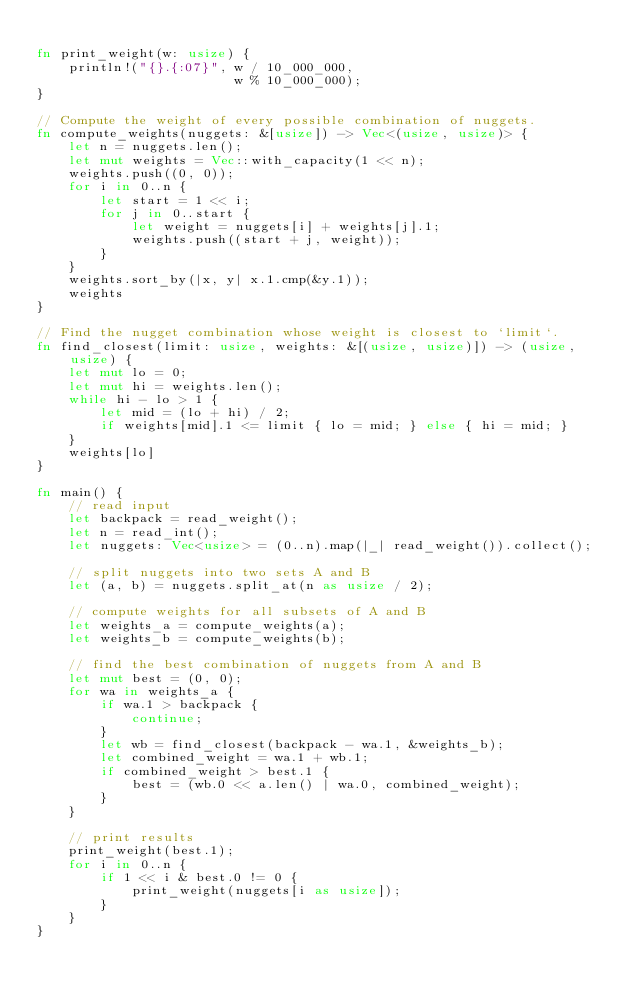<code> <loc_0><loc_0><loc_500><loc_500><_Rust_>
fn print_weight(w: usize) {
    println!("{}.{:07}", w / 10_000_000,
                         w % 10_000_000);
}

// Compute the weight of every possible combination of nuggets.
fn compute_weights(nuggets: &[usize]) -> Vec<(usize, usize)> {
    let n = nuggets.len();
    let mut weights = Vec::with_capacity(1 << n);
    weights.push((0, 0));
    for i in 0..n {
        let start = 1 << i;
        for j in 0..start {
            let weight = nuggets[i] + weights[j].1;
            weights.push((start + j, weight));
        }
    }
    weights.sort_by(|x, y| x.1.cmp(&y.1));
    weights
}

// Find the nugget combination whose weight is closest to `limit`.
fn find_closest(limit: usize, weights: &[(usize, usize)]) -> (usize, usize) {
    let mut lo = 0;
    let mut hi = weights.len();
    while hi - lo > 1 {
        let mid = (lo + hi) / 2;
        if weights[mid].1 <= limit { lo = mid; } else { hi = mid; }
    }
    weights[lo]
}

fn main() {
    // read input
    let backpack = read_weight();
    let n = read_int();
    let nuggets: Vec<usize> = (0..n).map(|_| read_weight()).collect();

    // split nuggets into two sets A and B
    let (a, b) = nuggets.split_at(n as usize / 2);

    // compute weights for all subsets of A and B
    let weights_a = compute_weights(a);
    let weights_b = compute_weights(b);

    // find the best combination of nuggets from A and B
    let mut best = (0, 0);
    for wa in weights_a {
        if wa.1 > backpack {
            continue;
        }
        let wb = find_closest(backpack - wa.1, &weights_b);
        let combined_weight = wa.1 + wb.1;
        if combined_weight > best.1 {
            best = (wb.0 << a.len() | wa.0, combined_weight);
        }
    }

    // print results
    print_weight(best.1);
    for i in 0..n {
        if 1 << i & best.0 != 0 {
            print_weight(nuggets[i as usize]);
        }
    }
}
</code> 